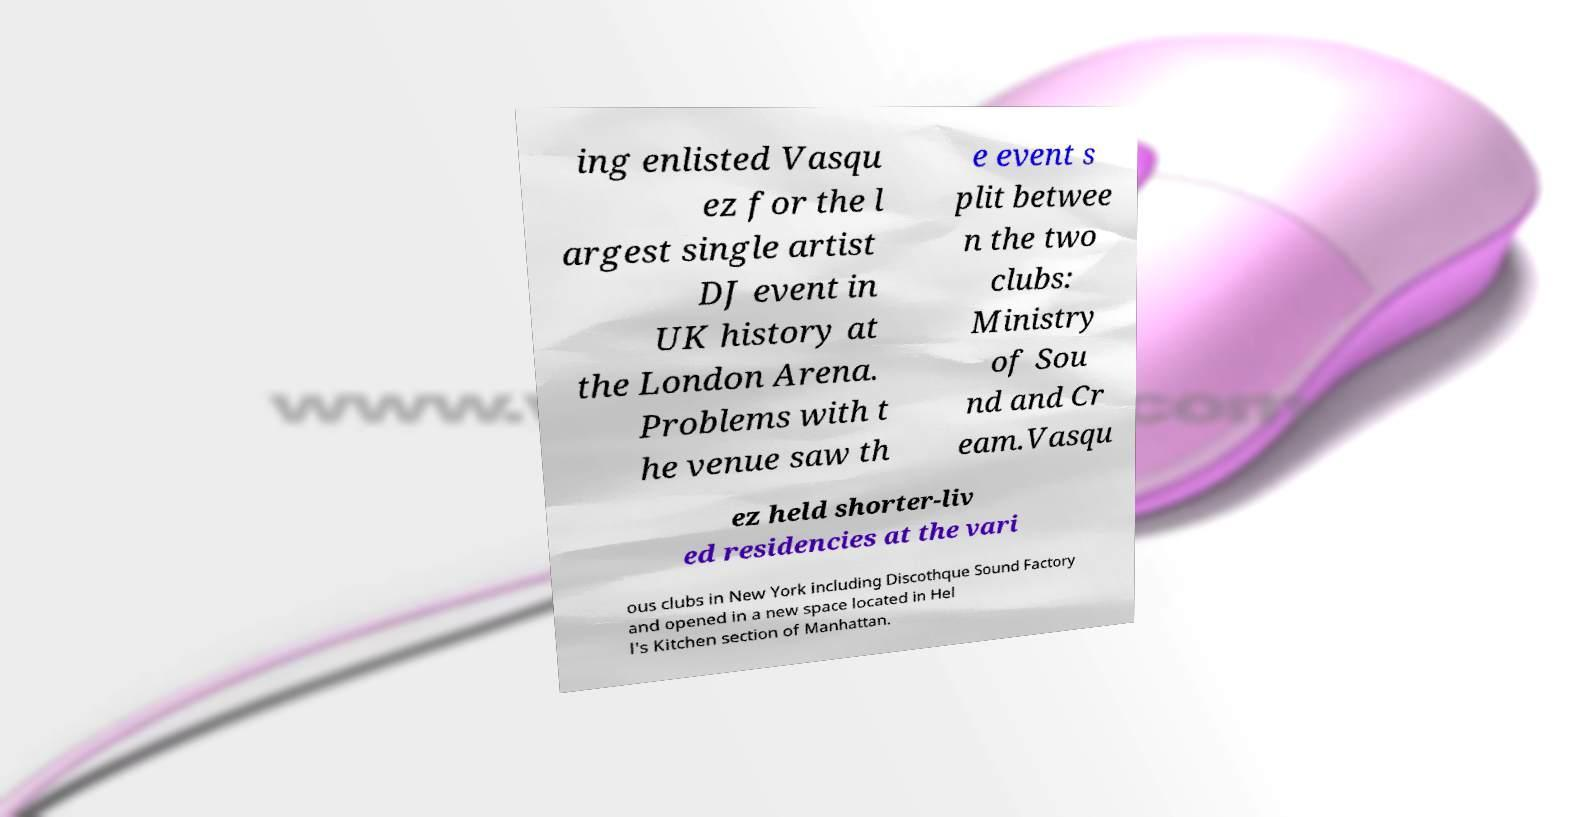What messages or text are displayed in this image? I need them in a readable, typed format. ing enlisted Vasqu ez for the l argest single artist DJ event in UK history at the London Arena. Problems with t he venue saw th e event s plit betwee n the two clubs: Ministry of Sou nd and Cr eam.Vasqu ez held shorter-liv ed residencies at the vari ous clubs in New York including Discothque Sound Factory and opened in a new space located in Hel l's Kitchen section of Manhattan. 